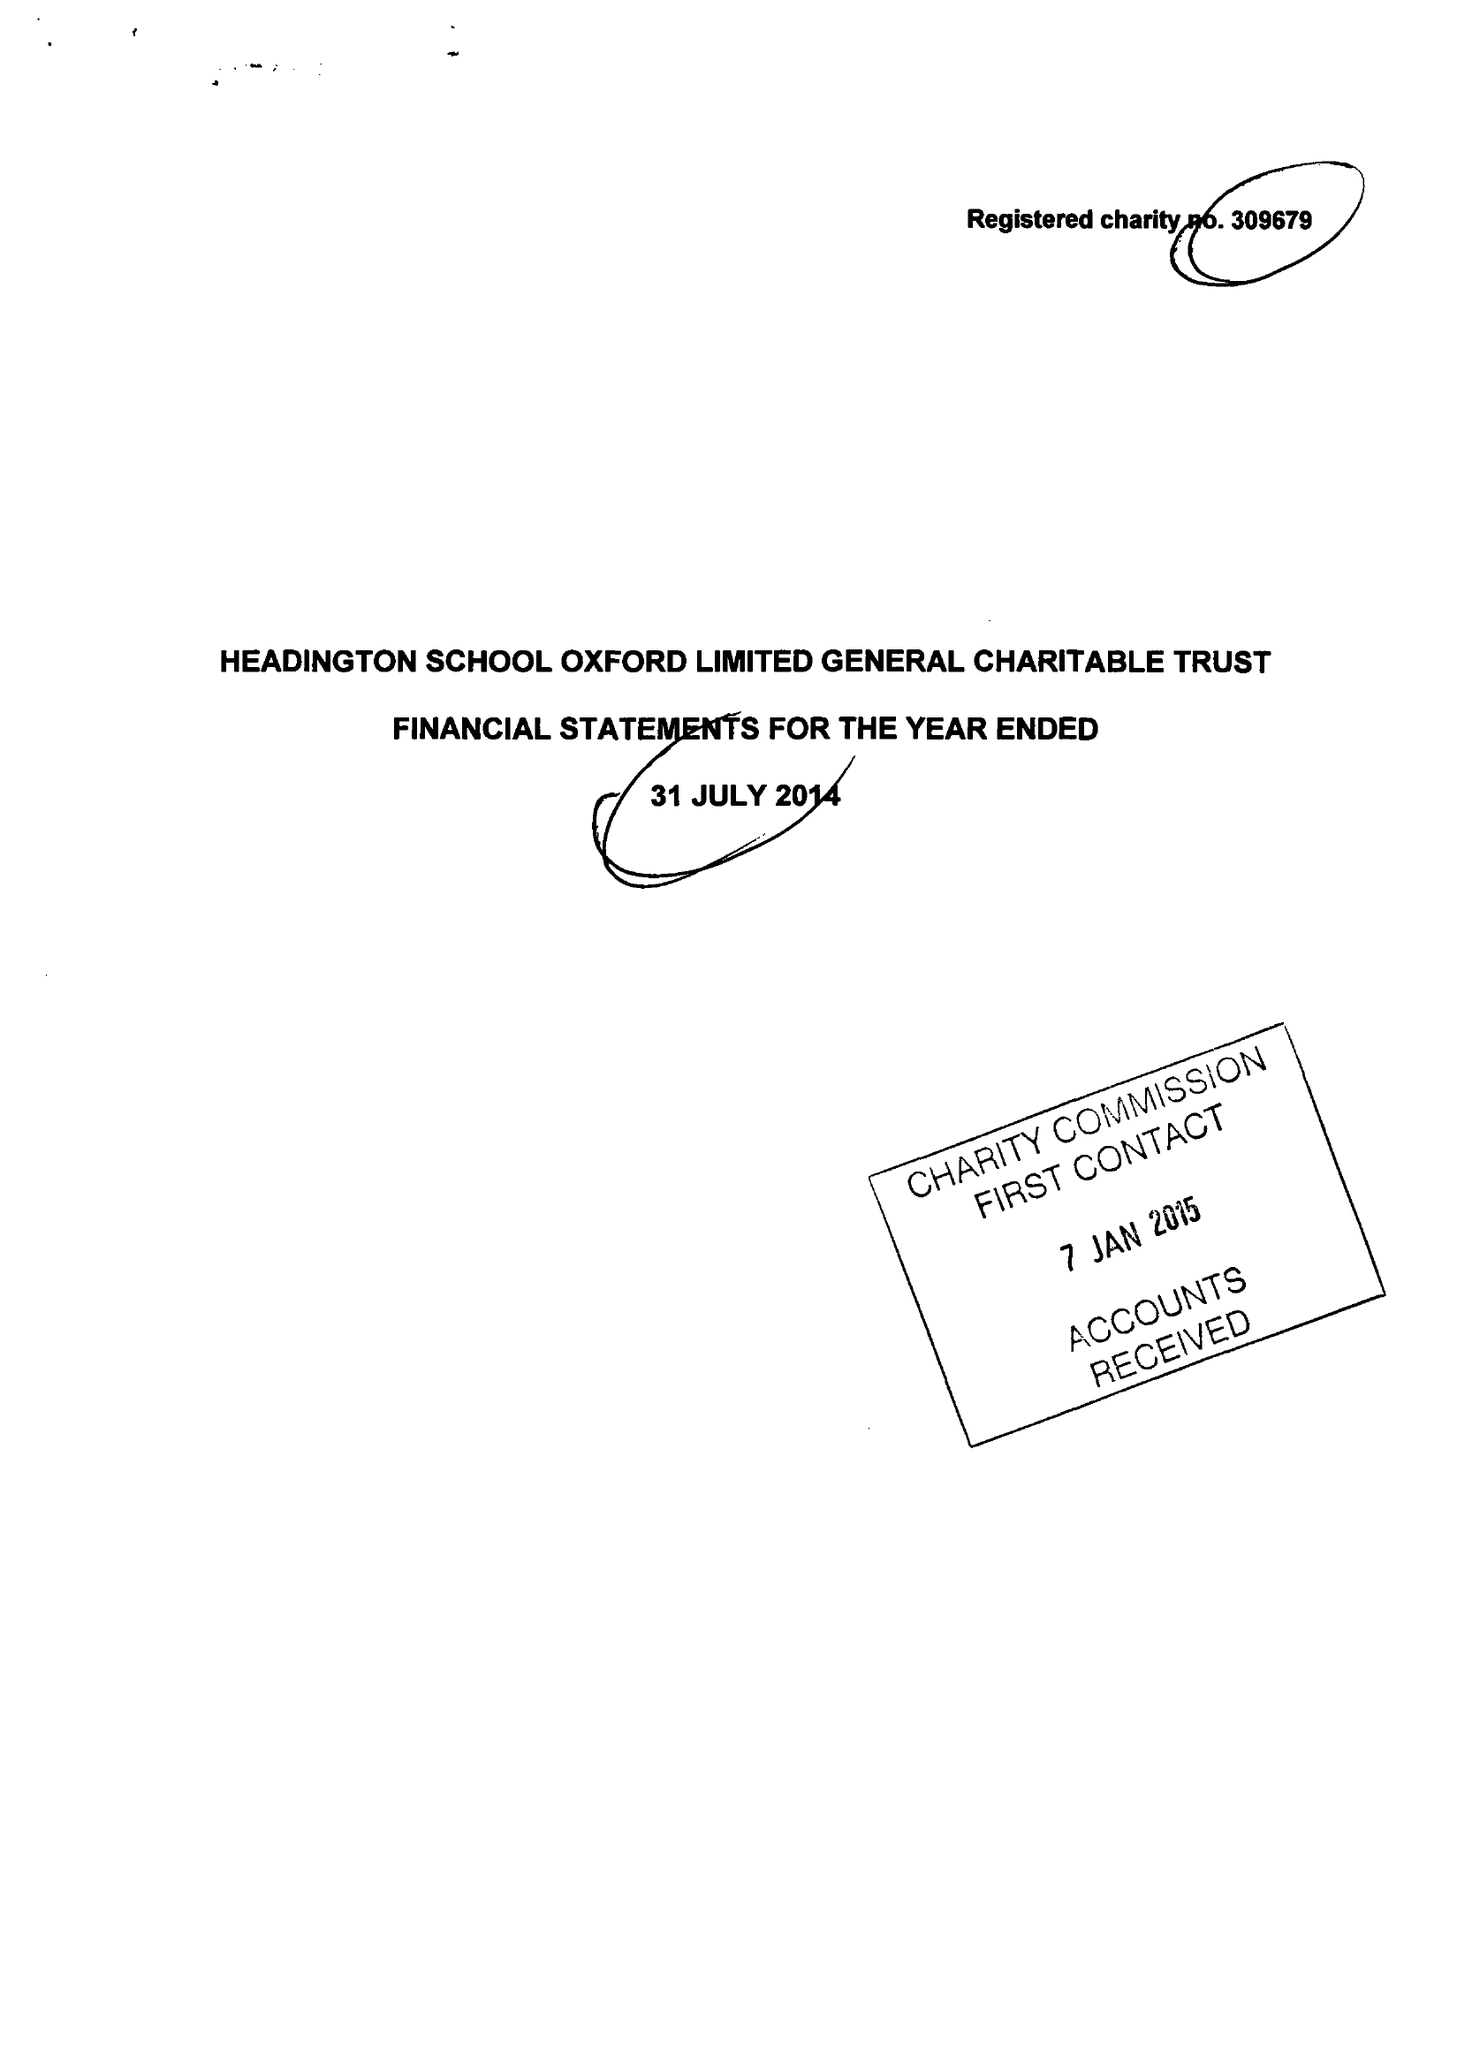What is the value for the charity_name?
Answer the question using a single word or phrase. Headington School Oxford Ltd. 